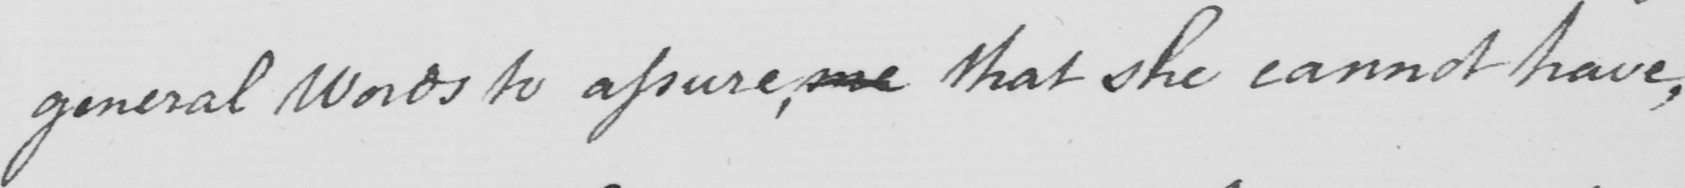Please transcribe the handwritten text in this image. general Words to assure, me that she cannot have, 